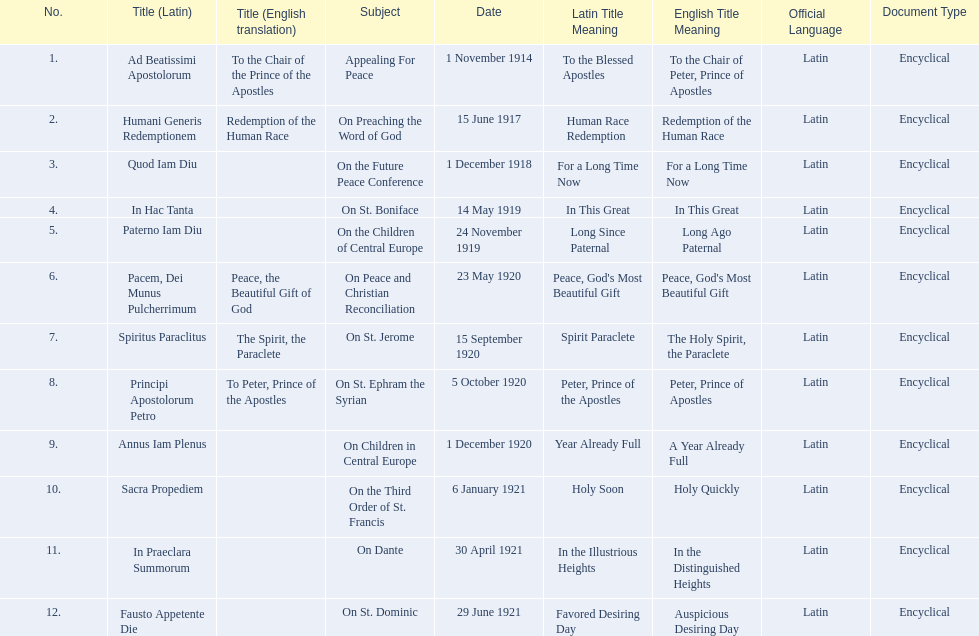What is the dates of the list of encyclicals of pope benedict xv? 1 November 1914, 15 June 1917, 1 December 1918, 14 May 1919, 24 November 1919, 23 May 1920, 15 September 1920, 5 October 1920, 1 December 1920, 6 January 1921, 30 April 1921, 29 June 1921. Of these dates, which subject was on 23 may 1920? On Peace and Christian Reconciliation. 